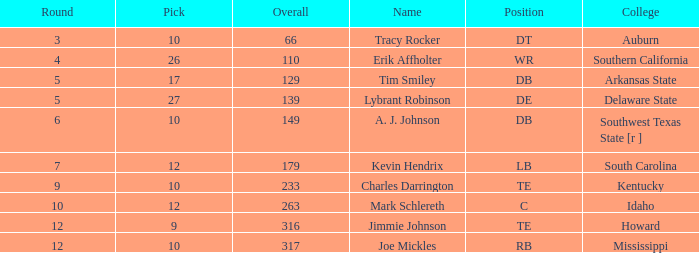What is the median pick, when name is "lybrant robinson", and when overall is under 139? None. 